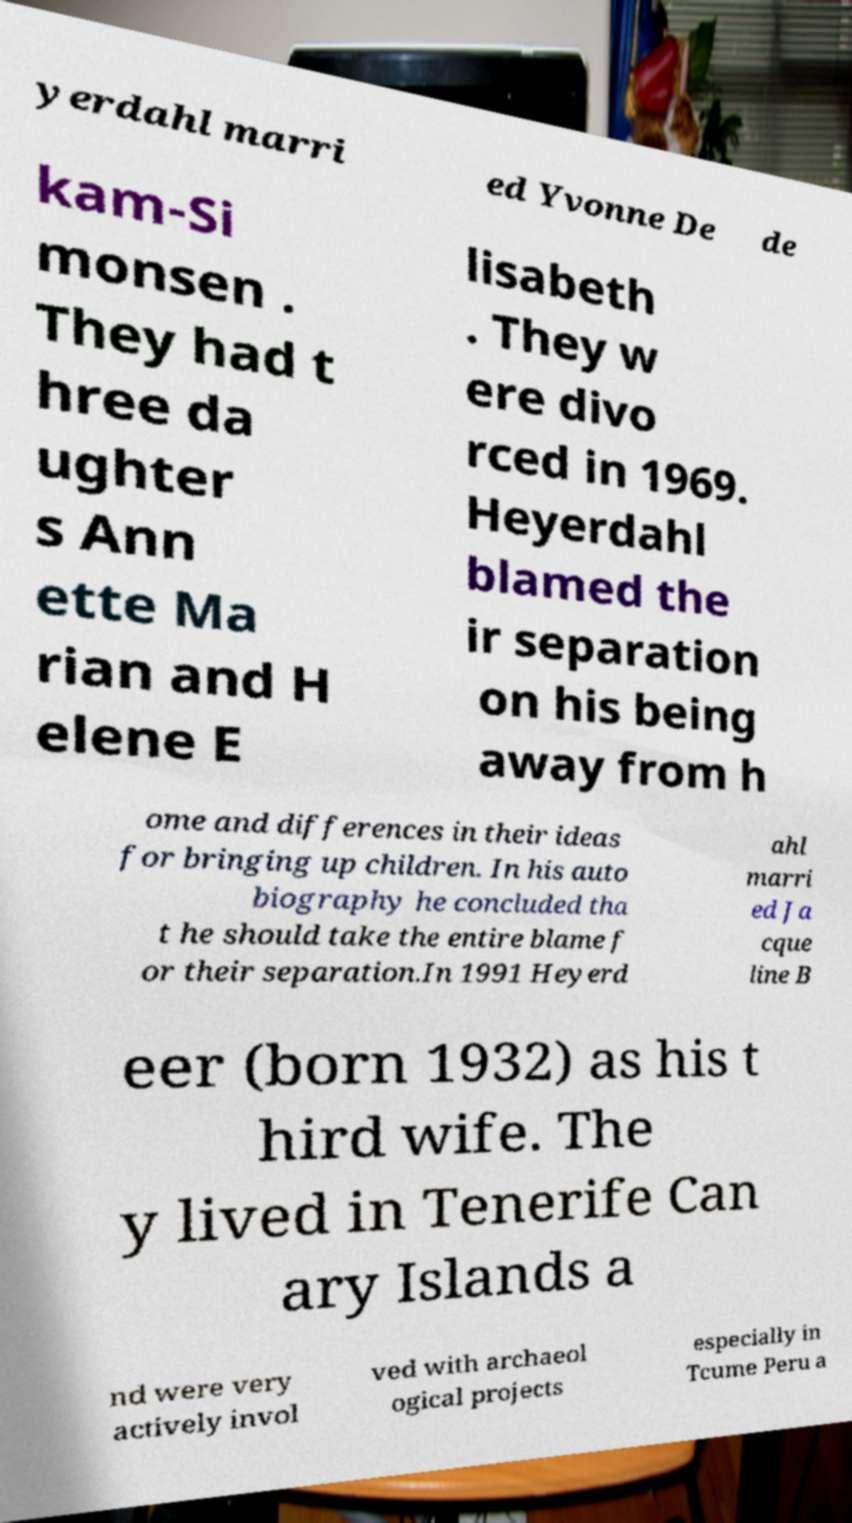There's text embedded in this image that I need extracted. Can you transcribe it verbatim? yerdahl marri ed Yvonne De de kam-Si monsen . They had t hree da ughter s Ann ette Ma rian and H elene E lisabeth . They w ere divo rced in 1969. Heyerdahl blamed the ir separation on his being away from h ome and differences in their ideas for bringing up children. In his auto biography he concluded tha t he should take the entire blame f or their separation.In 1991 Heyerd ahl marri ed Ja cque line B eer (born 1932) as his t hird wife. The y lived in Tenerife Can ary Islands a nd were very actively invol ved with archaeol ogical projects especially in Tcume Peru a 